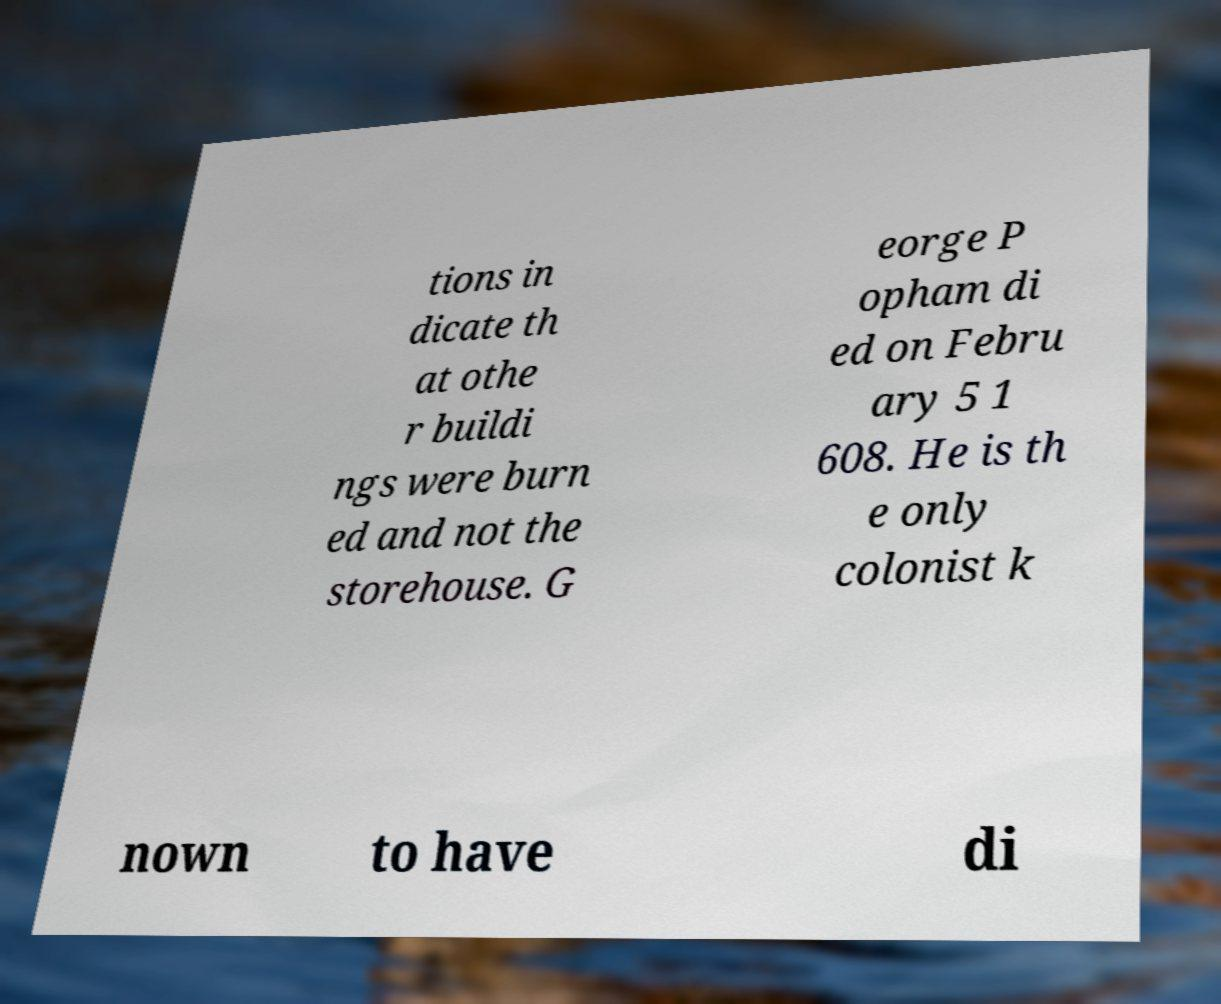Can you accurately transcribe the text from the provided image for me? tions in dicate th at othe r buildi ngs were burn ed and not the storehouse. G eorge P opham di ed on Febru ary 5 1 608. He is th e only colonist k nown to have di 